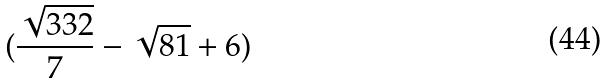<formula> <loc_0><loc_0><loc_500><loc_500>( \frac { \sqrt { 3 3 2 } } { 7 } - \sqrt { 8 1 } + 6 )</formula> 